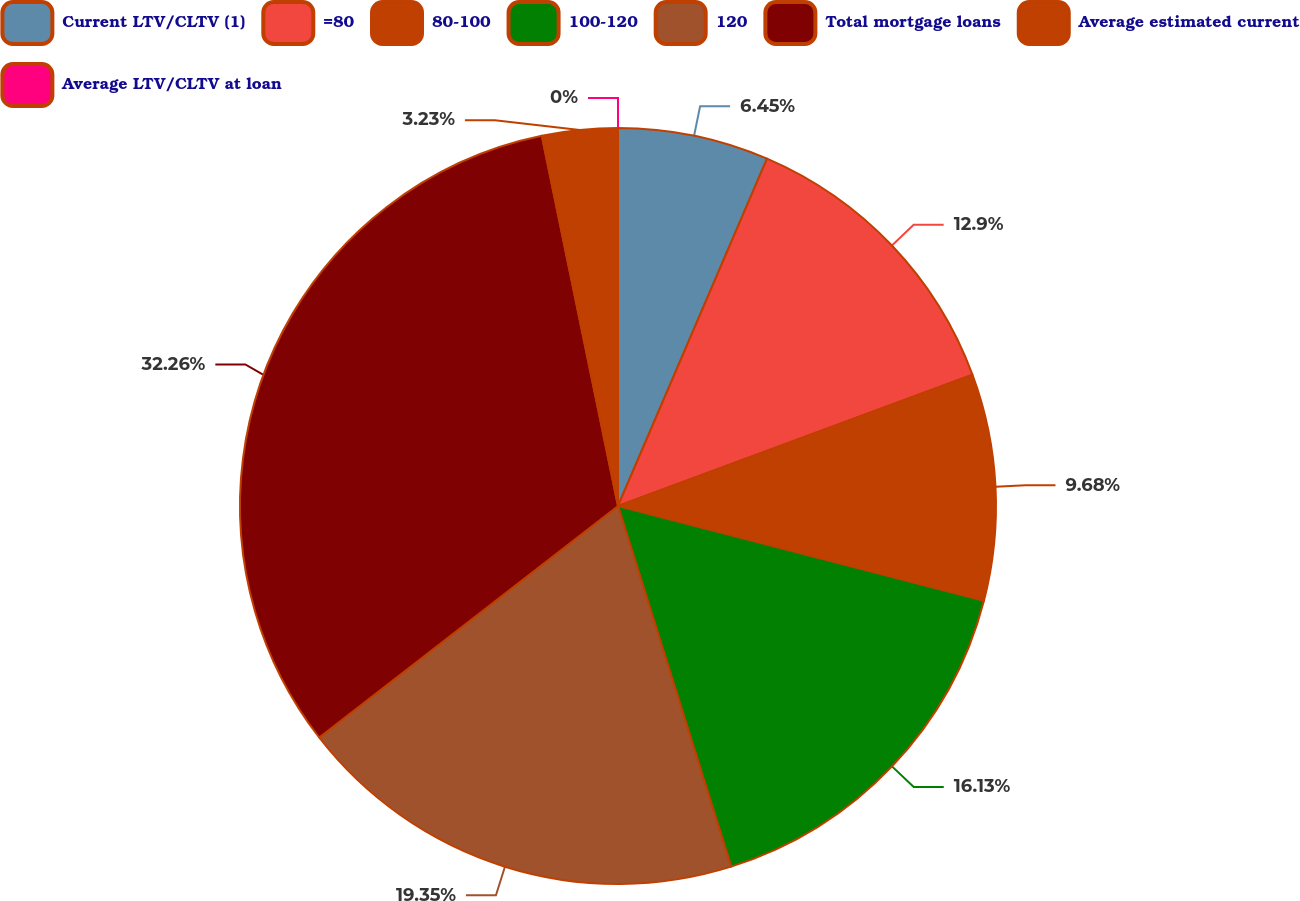Convert chart to OTSL. <chart><loc_0><loc_0><loc_500><loc_500><pie_chart><fcel>Current LTV/CLTV (1)<fcel>=80<fcel>80-100<fcel>100-120<fcel>120<fcel>Total mortgage loans<fcel>Average estimated current<fcel>Average LTV/CLTV at loan<nl><fcel>6.45%<fcel>12.9%<fcel>9.68%<fcel>16.13%<fcel>19.35%<fcel>32.26%<fcel>3.23%<fcel>0.0%<nl></chart> 